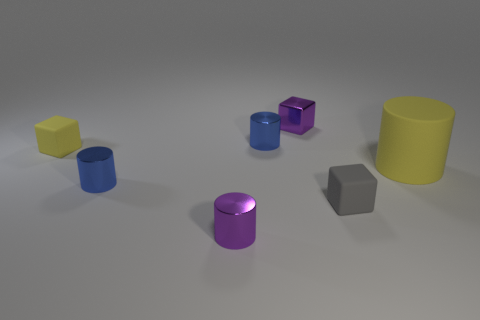What material is the tiny cylinder that is the same color as the metal cube?
Offer a very short reply. Metal. What is the material of the small yellow thing that is the same shape as the tiny gray matte thing?
Your response must be concise. Rubber. There is a purple thing that is the same size as the purple cylinder; what is its shape?
Make the answer very short. Cube. Is there a large cyan metallic thing of the same shape as the tiny yellow matte object?
Provide a short and direct response. No. The purple metallic thing that is behind the blue metallic object in front of the large rubber cylinder is what shape?
Ensure brevity in your answer.  Cube. There is a gray matte thing; what shape is it?
Your answer should be compact. Cube. What is the small purple thing that is to the left of the blue cylinder that is behind the blue metallic cylinder that is in front of the small yellow matte object made of?
Give a very brief answer. Metal. How many other things are made of the same material as the purple cube?
Keep it short and to the point. 3. There is a small purple shiny thing on the left side of the metal block; what number of blue metallic cylinders are left of it?
Keep it short and to the point. 1. What number of cubes are blue things or shiny things?
Provide a short and direct response. 1. 